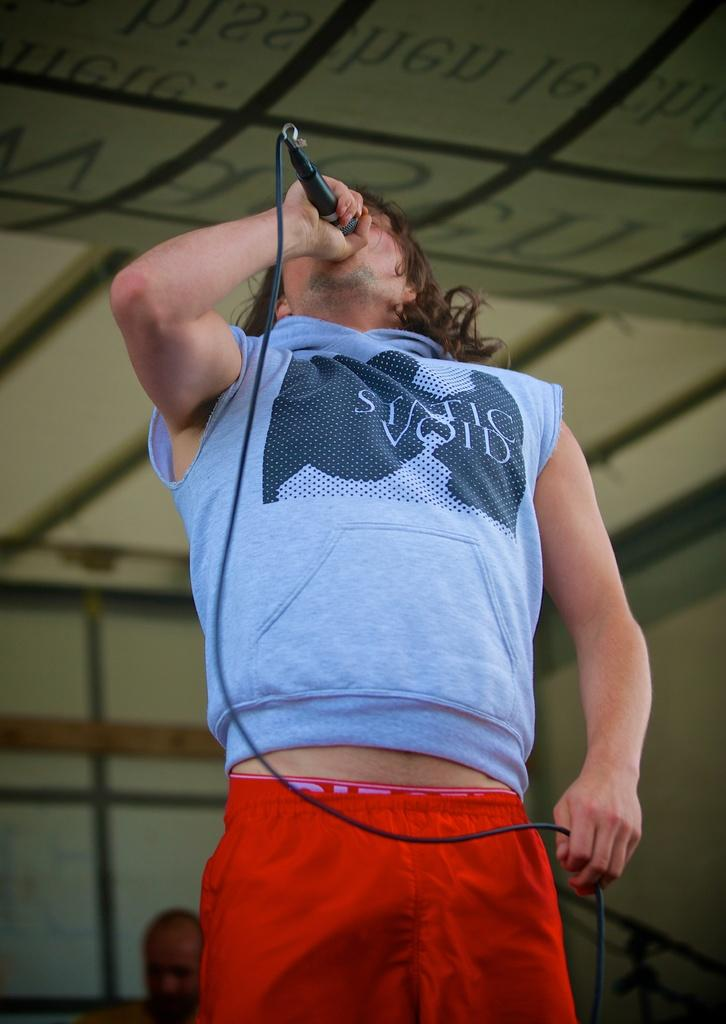<image>
Provide a brief description of the given image. A man holding a microphone is wearing a Static Void shirt. 